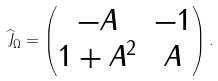<formula> <loc_0><loc_0><loc_500><loc_500>\widehat { J } _ { \Omega } = \begin{pmatrix} - A & - 1 \\ 1 + A ^ { 2 } & A \end{pmatrix} .</formula> 